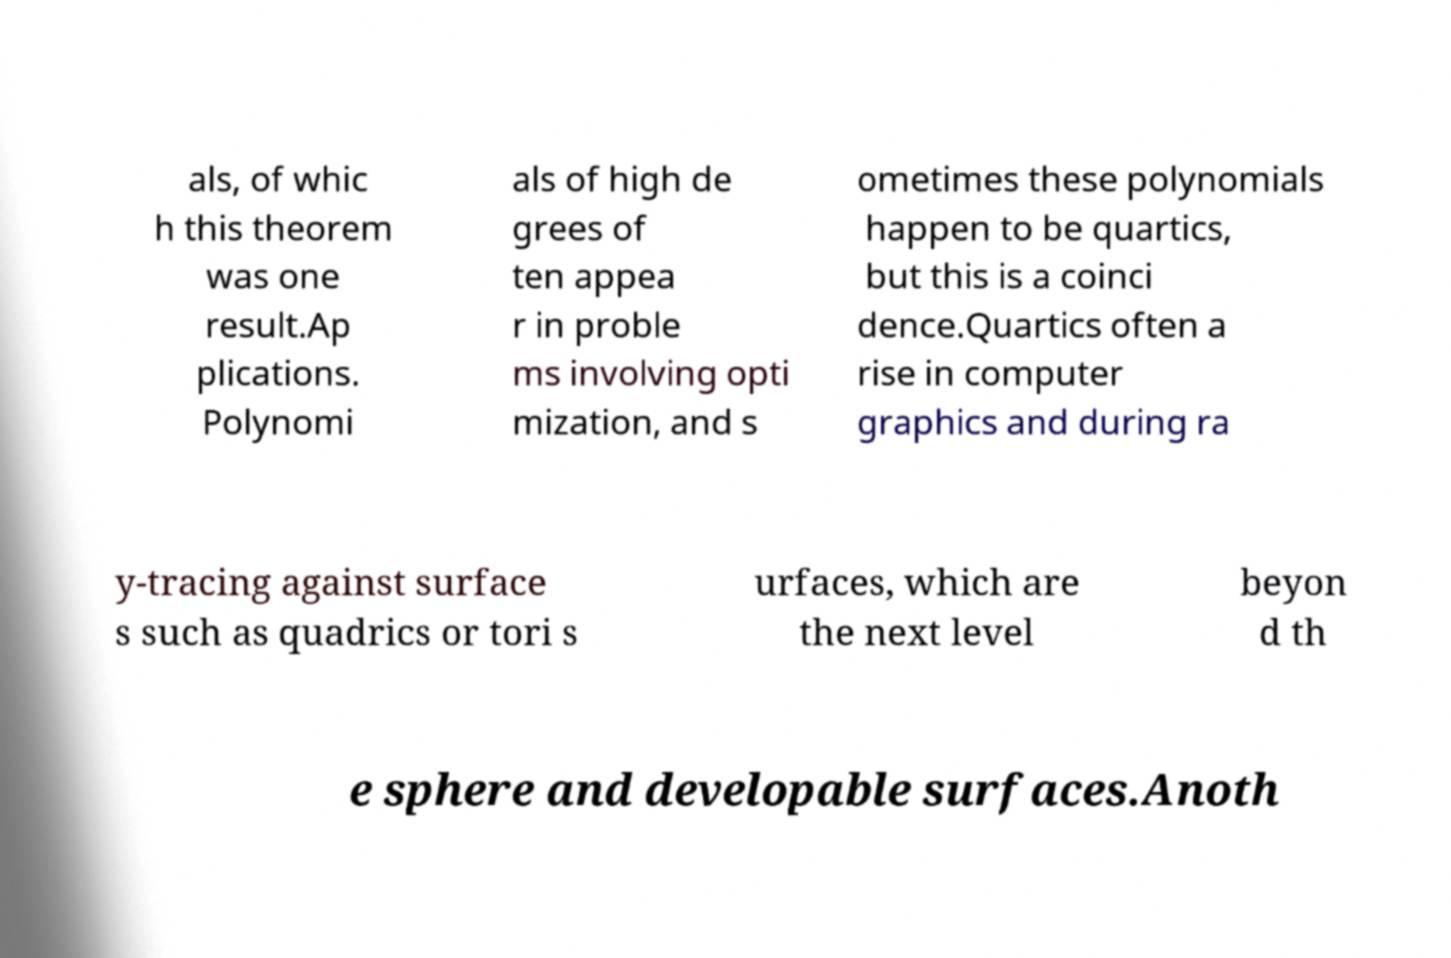There's text embedded in this image that I need extracted. Can you transcribe it verbatim? als, of whic h this theorem was one result.Ap plications. Polynomi als of high de grees of ten appea r in proble ms involving opti mization, and s ometimes these polynomials happen to be quartics, but this is a coinci dence.Quartics often a rise in computer graphics and during ra y-tracing against surface s such as quadrics or tori s urfaces, which are the next level beyon d th e sphere and developable surfaces.Anoth 